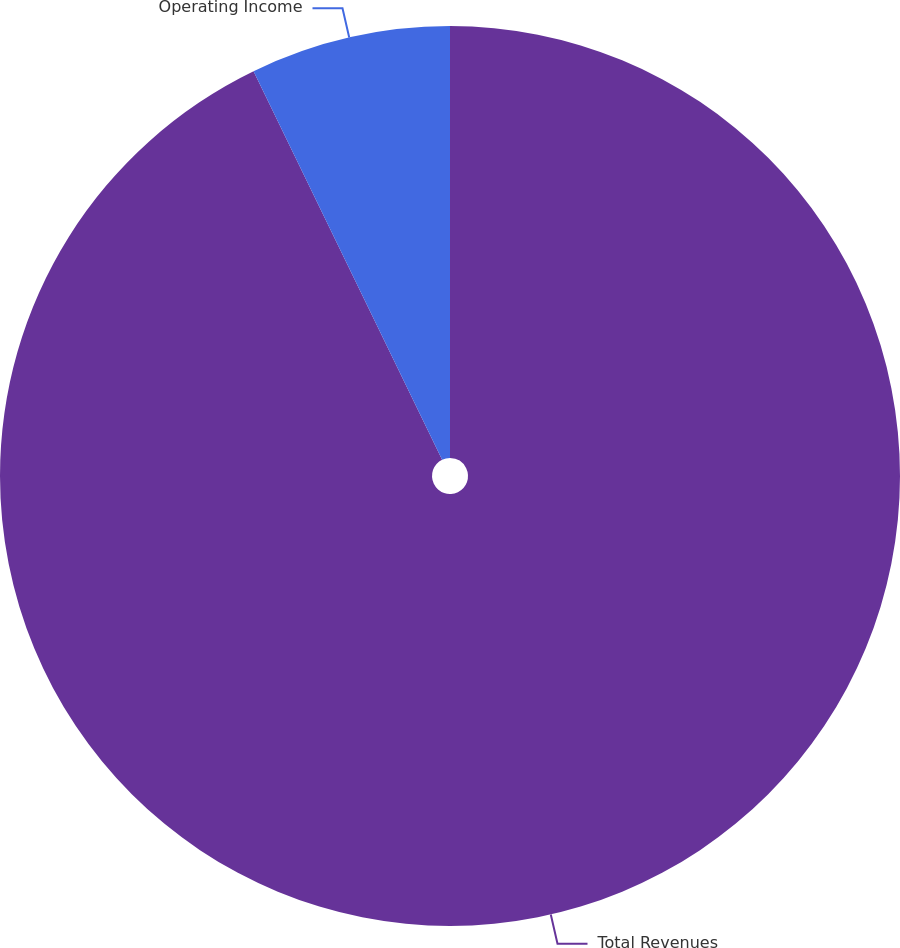Convert chart to OTSL. <chart><loc_0><loc_0><loc_500><loc_500><pie_chart><fcel>Total Revenues<fcel>Operating Income<nl><fcel>92.81%<fcel>7.19%<nl></chart> 